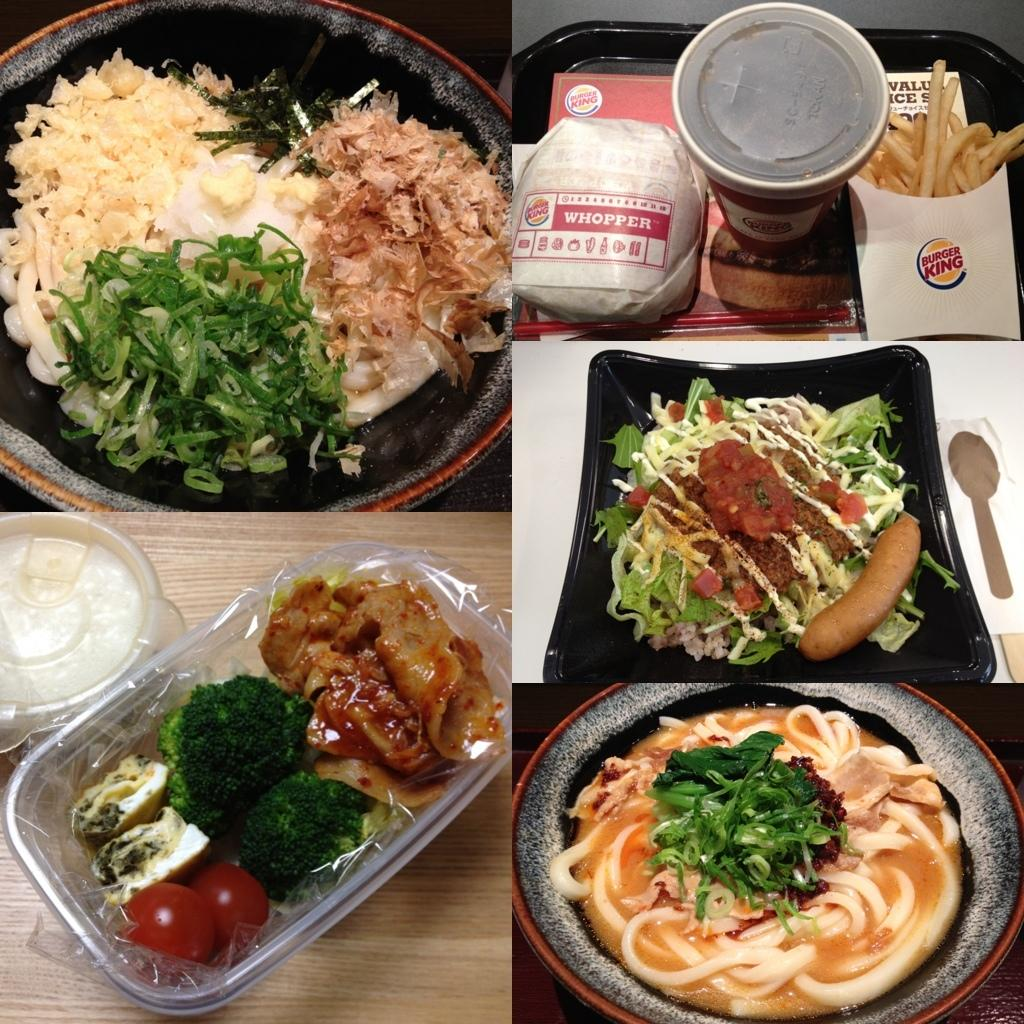What types of food items can be seen in the image? The food items in the image have green, brown, white, and red colors. How are the food items arranged in the image? The food items are in plates and bowls. What is the color of the plates in the image? The plates are black in color. Can you see a robin sitting on the letter on the sofa in the image? There is no robin, letter, or sofa present in the image. 